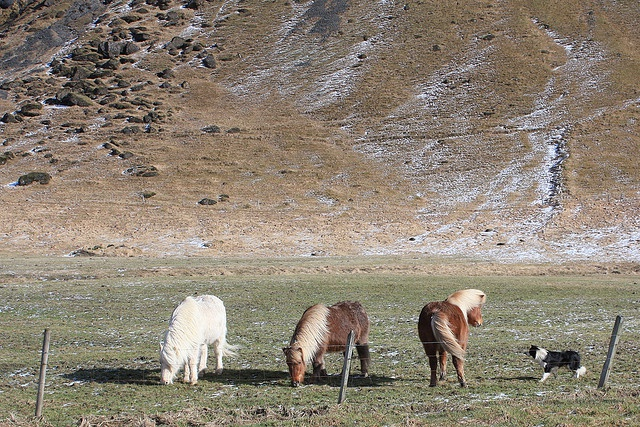Describe the objects in this image and their specific colors. I can see horse in black, gray, and maroon tones, horse in black, white, darkgray, gray, and lightgray tones, horse in black, gray, maroon, and ivory tones, and dog in black, lightgray, gray, and darkgray tones in this image. 